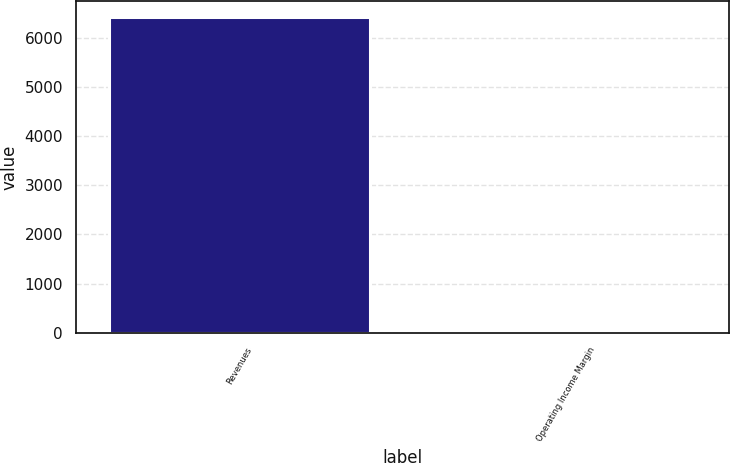<chart> <loc_0><loc_0><loc_500><loc_500><bar_chart><fcel>Revenues<fcel>Operating Income Margin<nl><fcel>6426.6<fcel>13.7<nl></chart> 